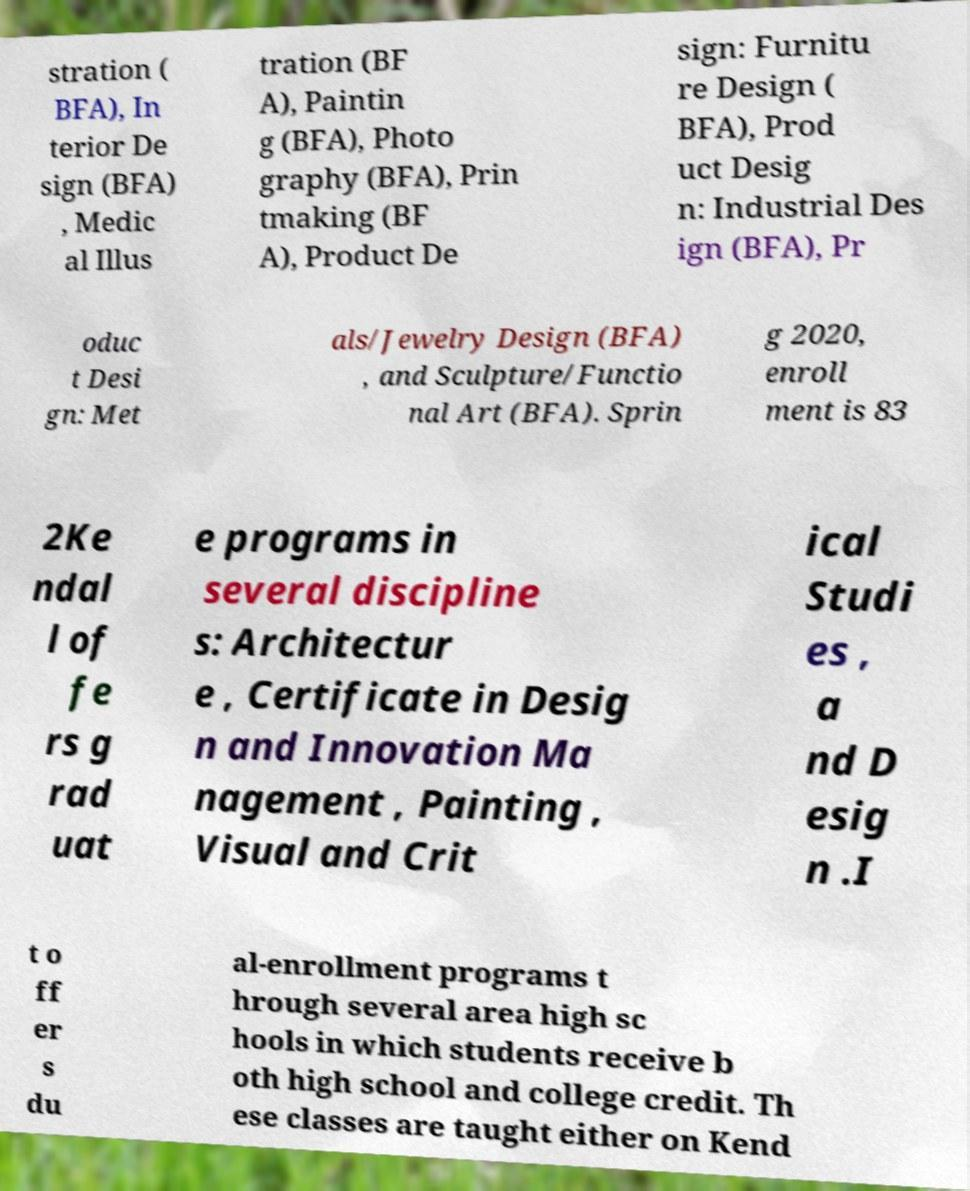Could you assist in decoding the text presented in this image and type it out clearly? stration ( BFA), In terior De sign (BFA) , Medic al Illus tration (BF A), Paintin g (BFA), Photo graphy (BFA), Prin tmaking (BF A), Product De sign: Furnitu re Design ( BFA), Prod uct Desig n: Industrial Des ign (BFA), Pr oduc t Desi gn: Met als/Jewelry Design (BFA) , and Sculpture/Functio nal Art (BFA). Sprin g 2020, enroll ment is 83 2Ke ndal l of fe rs g rad uat e programs in several discipline s: Architectur e , Certificate in Desig n and Innovation Ma nagement , Painting , Visual and Crit ical Studi es , a nd D esig n .I t o ff er s du al-enrollment programs t hrough several area high sc hools in which students receive b oth high school and college credit. Th ese classes are taught either on Kend 